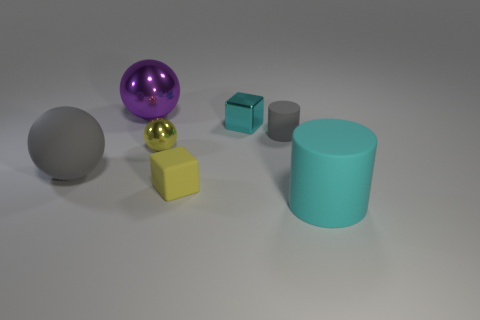Add 1 large spheres. How many objects exist? 8 Subtract all balls. How many objects are left? 4 Add 2 large purple balls. How many large purple balls exist? 3 Subtract 0 green balls. How many objects are left? 7 Subtract all tiny yellow spheres. Subtract all large cyan shiny objects. How many objects are left? 6 Add 2 tiny yellow things. How many tiny yellow things are left? 4 